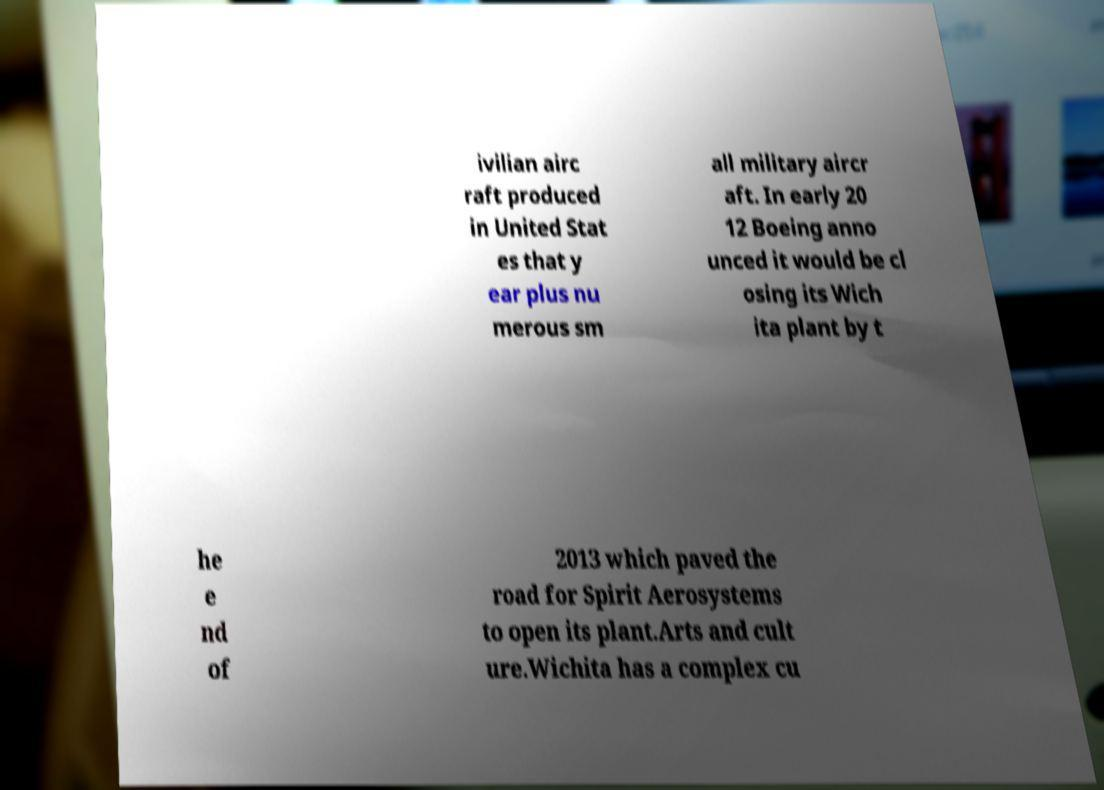Could you extract and type out the text from this image? ivilian airc raft produced in United Stat es that y ear plus nu merous sm all military aircr aft. In early 20 12 Boeing anno unced it would be cl osing its Wich ita plant by t he e nd of 2013 which paved the road for Spirit Aerosystems to open its plant.Arts and cult ure.Wichita has a complex cu 